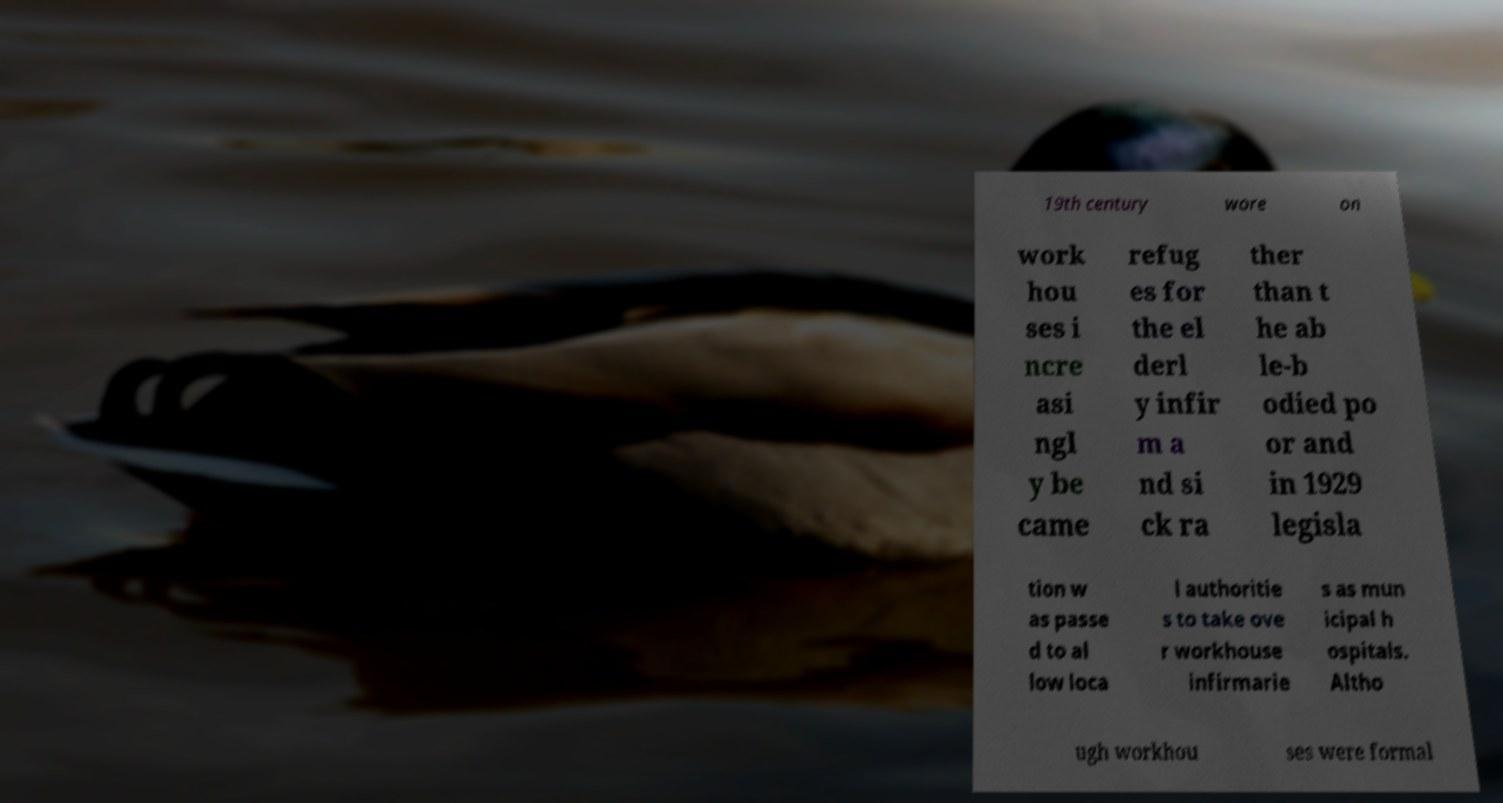There's text embedded in this image that I need extracted. Can you transcribe it verbatim? 19th century wore on work hou ses i ncre asi ngl y be came refug es for the el derl y infir m a nd si ck ra ther than t he ab le-b odied po or and in 1929 legisla tion w as passe d to al low loca l authoritie s to take ove r workhouse infirmarie s as mun icipal h ospitals. Altho ugh workhou ses were formal 